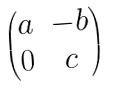Convert formula to latex. <formula><loc_0><loc_0><loc_500><loc_500>\begin{pmatrix} a & - b \\ 0 & c \end{pmatrix}</formula> 